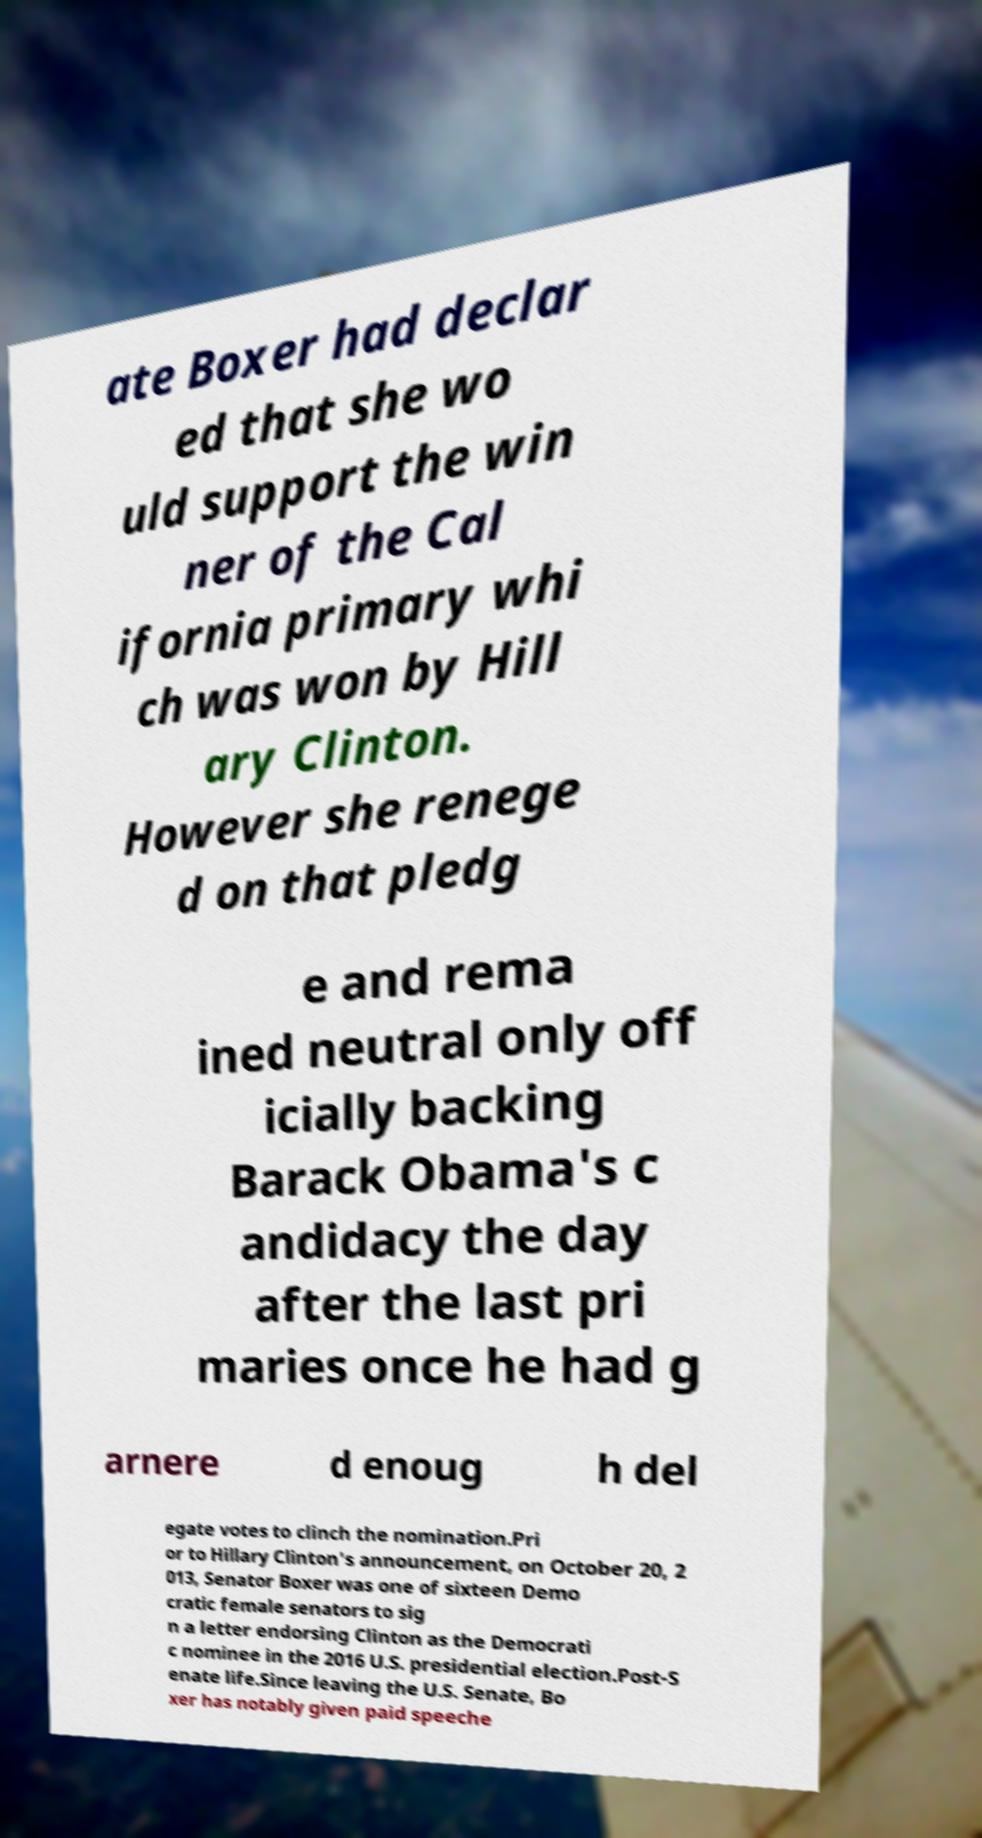What messages or text are displayed in this image? I need them in a readable, typed format. ate Boxer had declar ed that she wo uld support the win ner of the Cal ifornia primary whi ch was won by Hill ary Clinton. However she renege d on that pledg e and rema ined neutral only off icially backing Barack Obama's c andidacy the day after the last pri maries once he had g arnere d enoug h del egate votes to clinch the nomination.Pri or to Hillary Clinton's announcement, on October 20, 2 013, Senator Boxer was one of sixteen Demo cratic female senators to sig n a letter endorsing Clinton as the Democrati c nominee in the 2016 U.S. presidential election.Post-S enate life.Since leaving the U.S. Senate, Bo xer has notably given paid speeche 